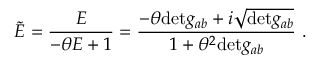Convert formula to latex. <formula><loc_0><loc_0><loc_500><loc_500>\tilde { E } = \frac { E } { - \theta E + 1 } = \frac { - \theta d e t g _ { a b } + i \sqrt { d e t g _ { a b } } } { 1 + \theta ^ { 2 } d e t g _ { a b } } \ .</formula> 